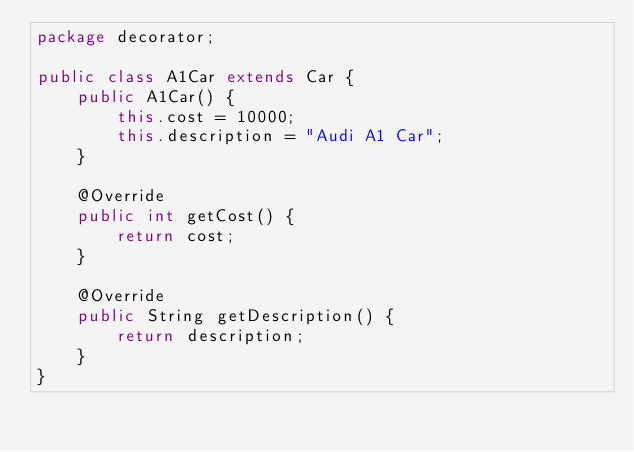Convert code to text. <code><loc_0><loc_0><loc_500><loc_500><_Java_>package decorator;

public class A1Car extends Car {
    public A1Car() {
        this.cost = 10000;
        this.description = "Audi A1 Car";
    }

    @Override
    public int getCost() {
        return cost;
    }

    @Override
    public String getDescription() {
        return description;
    }
}
</code> 